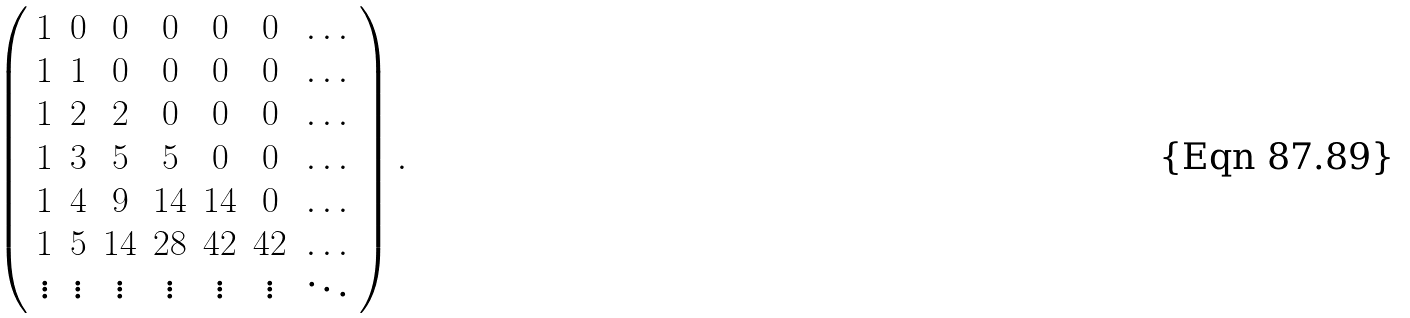<formula> <loc_0><loc_0><loc_500><loc_500>\left ( \begin{array} { c c c c c c c } 1 & 0 & 0 & 0 & 0 & 0 & \dots \\ 1 & 1 & 0 & 0 & 0 & 0 & \dots \\ 1 & 2 & 2 & 0 & 0 & 0 & \dots \\ 1 & 3 & 5 & 5 & 0 & 0 & \dots \\ 1 & 4 & 9 & 1 4 & 1 4 & 0 & \dots \\ 1 & 5 & 1 4 & 2 8 & 4 2 & 4 2 & \dots \\ \vdots & \vdots & \vdots & \vdots & \vdots & \vdots & \ddots \end{array} \right ) .</formula> 